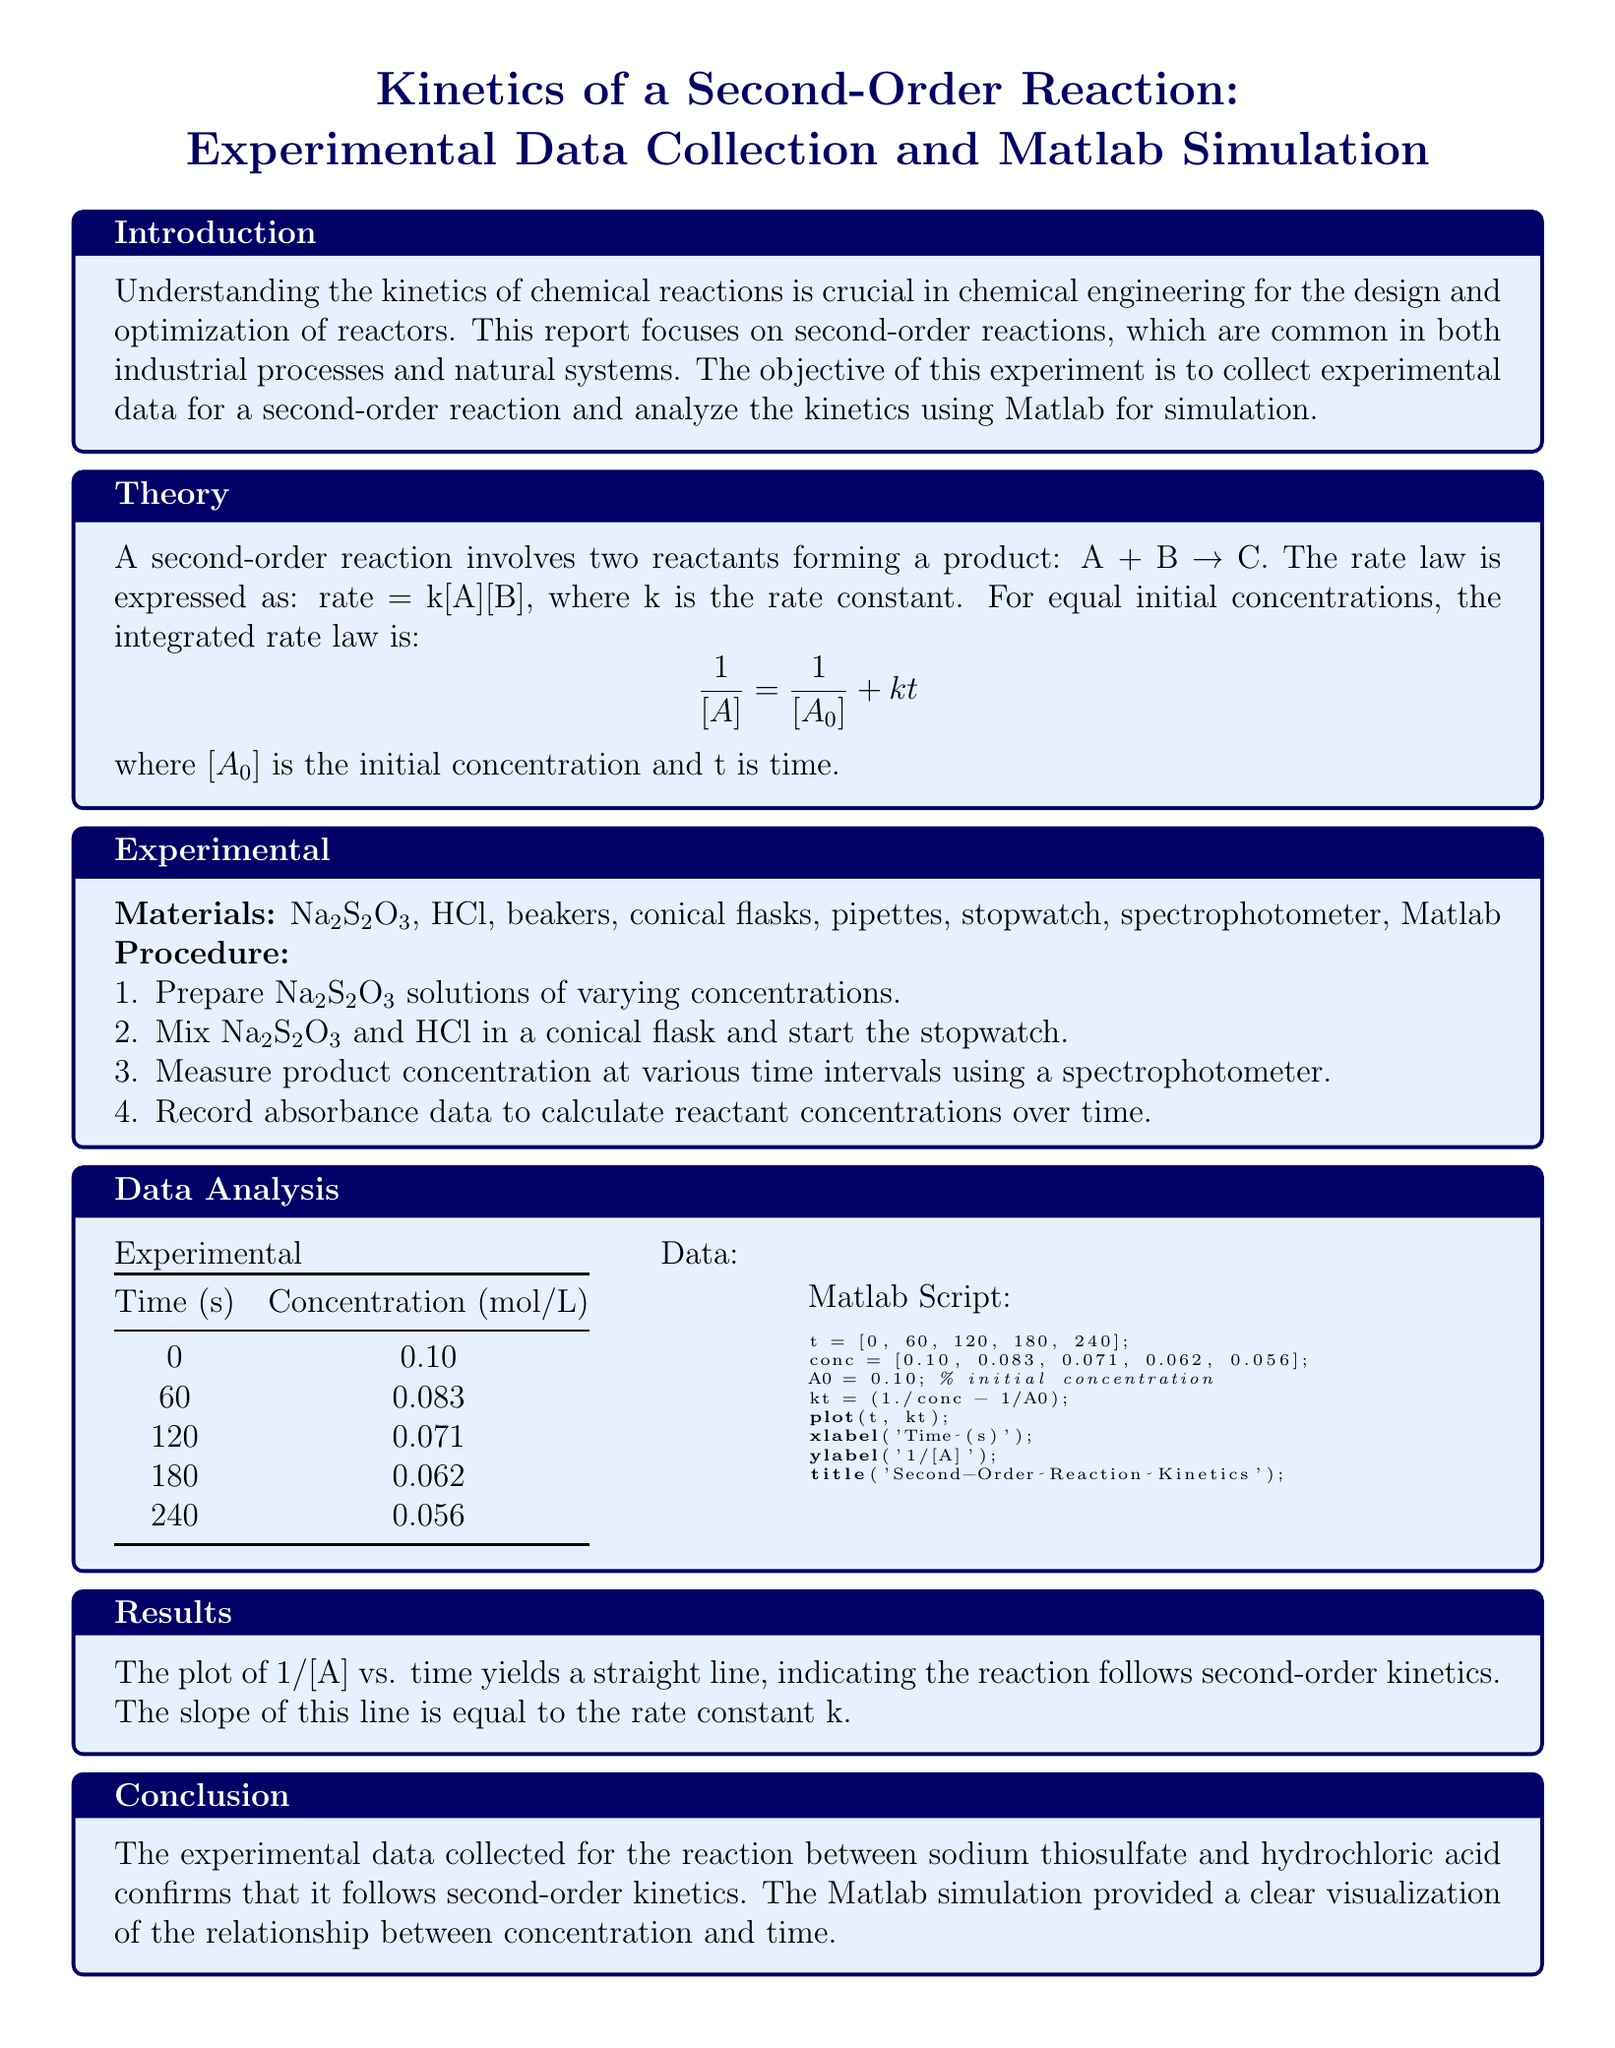what is the objective of the experiment? The objective of the experiment is to collect experimental data for a second-order reaction and analyze the kinetics using Matlab for simulation.
Answer: to collect experimental data for a second-order reaction and analyze the kinetics using Matlab for simulation what reaction does the report focus on? The report focuses on second-order reactions that involve two reactants forming a product.
Answer: second-order reactions what is the initial concentration denoted as in the theory section? The initial concentration is denoted as [A_0] in the integrated rate law equation.
Answer: [A_0] how many time intervals were measured in the experimental data? Five time intervals were measured, as shown in the experimental data table.
Answer: five which materials were used in the experiment? The materials used include Na₂S₂O₃, HCl, beakers, conical flasks, pipettes, stopwatch, spectrophotometer, and Matlab.
Answer: Na₂S₂O₃, HCl, beakers, conical flasks, pipettes, stopwatch, spectrophotometer, Matlab what was the concentration of the reactant at 180 seconds? The concentration of the reactant at 180 seconds is listed in the data table.
Answer: 0.062 what does the plot of 1/[A] versus time indicate? The plot indicates that the reaction follows second-order kinetics based on the linearity of the plot.
Answer: second-order kinetics what is the relationship between the slope of the line and the rate constant? The slope of the line is equal to the rate constant k for the second-order reaction.
Answer: equal to the rate constant k what conclusion is drawn from the experimental data? The conclusion states that the experimental data confirms the reaction follows second-order kinetics.
Answer: the reaction follows second-order kinetics 